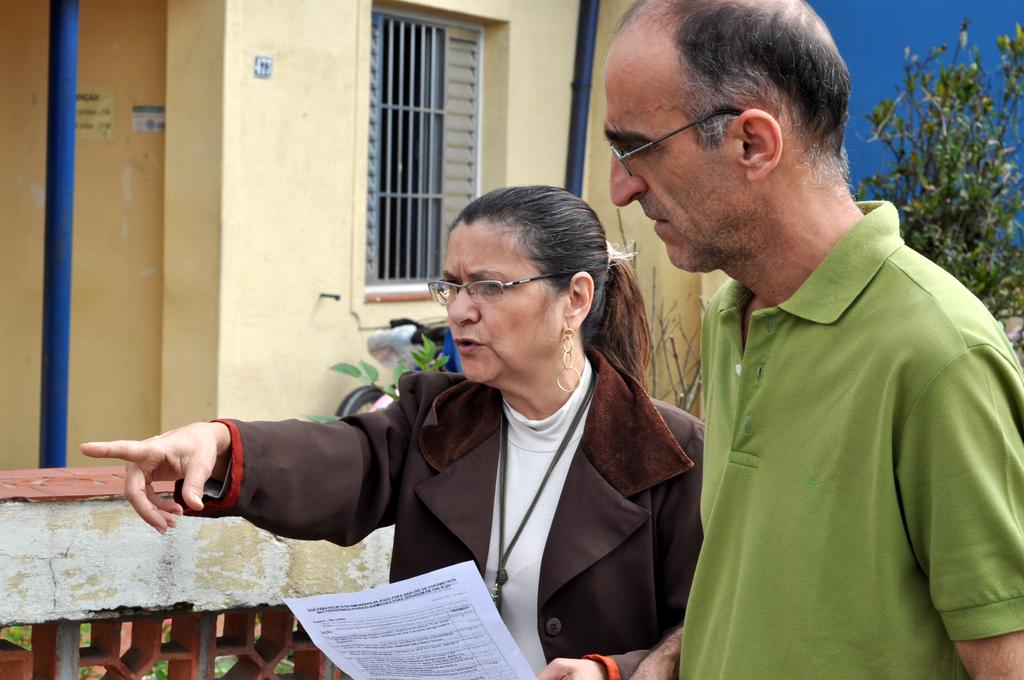What is the woman holding in the picture? The woman is holding a paper. Can you describe the background of the picture? There is a building and plants in the background of the picture. How many people are present in the image? There are two people, a man and a woman, present in the image. Where might this image have been taken, considering the background? The image might have been taken outdoors, given the presence of a building and plants in the background. What type of heat can be felt coming from the paper in the image? There is no indication of heat in the image, and the paper is not described as being warm or hot. Is there a balloon visible in the image? No, there is no balloon present in the image. 